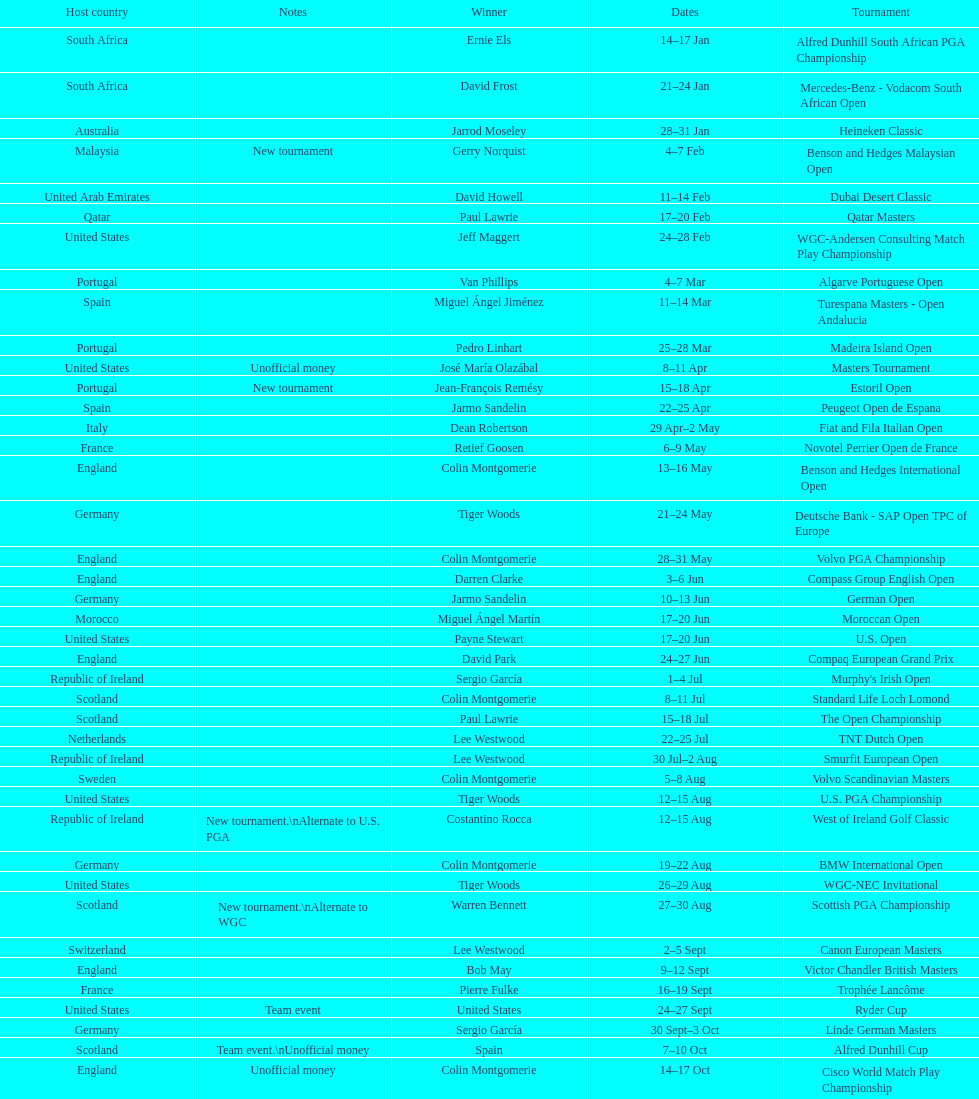What was the country listed the first time there was a new tournament? Malaysia. 